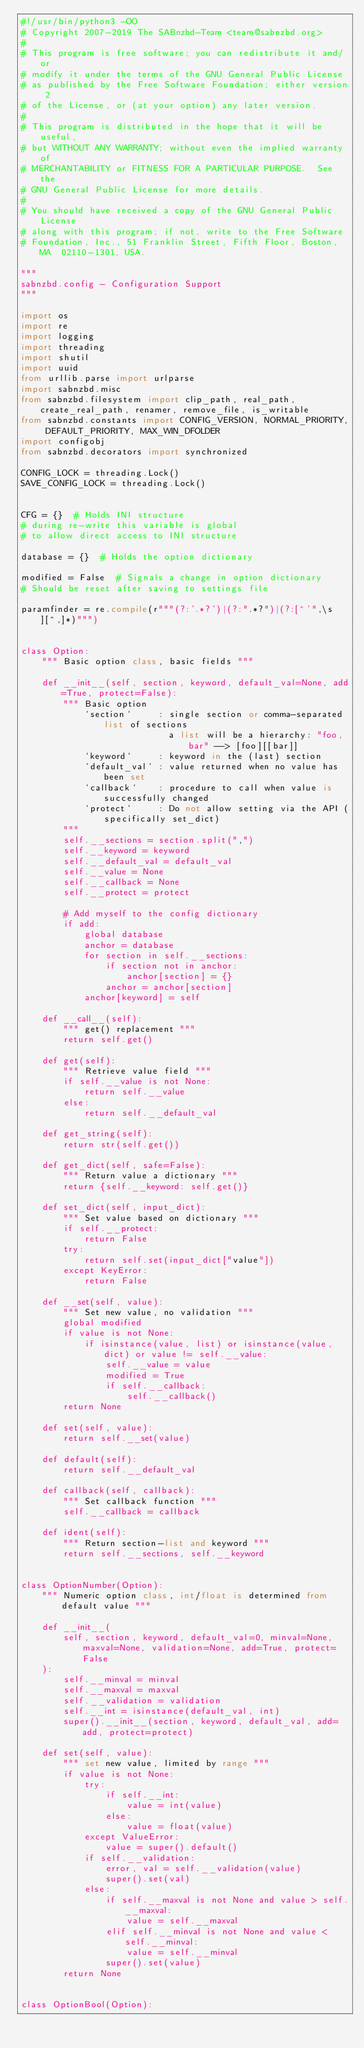Convert code to text. <code><loc_0><loc_0><loc_500><loc_500><_Python_>#!/usr/bin/python3 -OO
# Copyright 2007-2019 The SABnzbd-Team <team@sabnzbd.org>
#
# This program is free software; you can redistribute it and/or
# modify it under the terms of the GNU General Public License
# as published by the Free Software Foundation; either version 2
# of the License, or (at your option) any later version.
#
# This program is distributed in the hope that it will be useful,
# but WITHOUT ANY WARRANTY; without even the implied warranty of
# MERCHANTABILITY or FITNESS FOR A PARTICULAR PURPOSE.  See the
# GNU General Public License for more details.
#
# You should have received a copy of the GNU General Public License
# along with this program; if not, write to the Free Software
# Foundation, Inc., 51 Franklin Street, Fifth Floor, Boston, MA  02110-1301, USA.

"""
sabnzbd.config - Configuration Support
"""

import os
import re
import logging
import threading
import shutil
import uuid
from urllib.parse import urlparse
import sabnzbd.misc
from sabnzbd.filesystem import clip_path, real_path, create_real_path, renamer, remove_file, is_writable
from sabnzbd.constants import CONFIG_VERSION, NORMAL_PRIORITY, DEFAULT_PRIORITY, MAX_WIN_DFOLDER
import configobj
from sabnzbd.decorators import synchronized

CONFIG_LOCK = threading.Lock()
SAVE_CONFIG_LOCK = threading.Lock()


CFG = {}  # Holds INI structure
# during re-write this variable is global
# to allow direct access to INI structure

database = {}  # Holds the option dictionary

modified = False  # Signals a change in option dictionary
# Should be reset after saving to settings file

paramfinder = re.compile(r"""(?:'.*?')|(?:".*?")|(?:[^'",\s][^,]*)""")


class Option:
    """ Basic option class, basic fields """

    def __init__(self, section, keyword, default_val=None, add=True, protect=False):
        """ Basic option
            `section`     : single section or comma-separated list of sections
                            a list will be a hierarchy: "foo, bar" --> [foo][[bar]]
            `keyword`     : keyword in the (last) section
            `default_val` : value returned when no value has been set
            `callback`    : procedure to call when value is successfully changed
            `protect`     : Do not allow setting via the API (specifically set_dict)
        """
        self.__sections = section.split(",")
        self.__keyword = keyword
        self.__default_val = default_val
        self.__value = None
        self.__callback = None
        self.__protect = protect

        # Add myself to the config dictionary
        if add:
            global database
            anchor = database
            for section in self.__sections:
                if section not in anchor:
                    anchor[section] = {}
                anchor = anchor[section]
            anchor[keyword] = self

    def __call__(self):
        """ get() replacement """
        return self.get()

    def get(self):
        """ Retrieve value field """
        if self.__value is not None:
            return self.__value
        else:
            return self.__default_val

    def get_string(self):
        return str(self.get())

    def get_dict(self, safe=False):
        """ Return value a dictionary """
        return {self.__keyword: self.get()}

    def set_dict(self, input_dict):
        """ Set value based on dictionary """
        if self.__protect:
            return False
        try:
            return self.set(input_dict["value"])
        except KeyError:
            return False

    def __set(self, value):
        """ Set new value, no validation """
        global modified
        if value is not None:
            if isinstance(value, list) or isinstance(value, dict) or value != self.__value:
                self.__value = value
                modified = True
                if self.__callback:
                    self.__callback()
        return None

    def set(self, value):
        return self.__set(value)

    def default(self):
        return self.__default_val

    def callback(self, callback):
        """ Set callback function """
        self.__callback = callback

    def ident(self):
        """ Return section-list and keyword """
        return self.__sections, self.__keyword


class OptionNumber(Option):
    """ Numeric option class, int/float is determined from default value """

    def __init__(
        self, section, keyword, default_val=0, minval=None, maxval=None, validation=None, add=True, protect=False
    ):
        self.__minval = minval
        self.__maxval = maxval
        self.__validation = validation
        self.__int = isinstance(default_val, int)
        super().__init__(section, keyword, default_val, add=add, protect=protect)

    def set(self, value):
        """ set new value, limited by range """
        if value is not None:
            try:
                if self.__int:
                    value = int(value)
                else:
                    value = float(value)
            except ValueError:
                value = super().default()
            if self.__validation:
                error, val = self.__validation(value)
                super().set(val)
            else:
                if self.__maxval is not None and value > self.__maxval:
                    value = self.__maxval
                elif self.__minval is not None and value < self.__minval:
                    value = self.__minval
                super().set(value)
        return None


class OptionBool(Option):</code> 